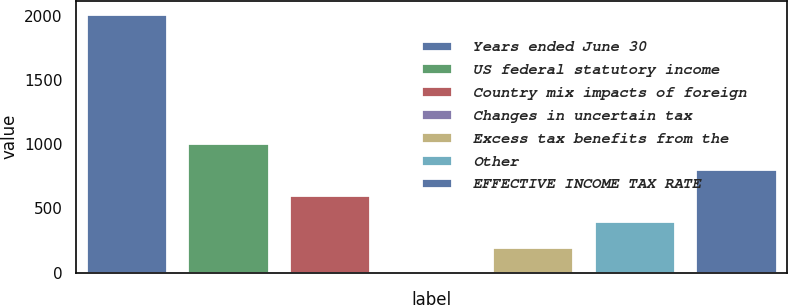Convert chart. <chart><loc_0><loc_0><loc_500><loc_500><bar_chart><fcel>Years ended June 30<fcel>US federal statutory income<fcel>Country mix impacts of foreign<fcel>Changes in uncertain tax<fcel>Excess tax benefits from the<fcel>Other<fcel>EFFECTIVE INCOME TAX RATE<nl><fcel>2018<fcel>1009.15<fcel>605.61<fcel>0.3<fcel>202.07<fcel>403.84<fcel>807.38<nl></chart> 